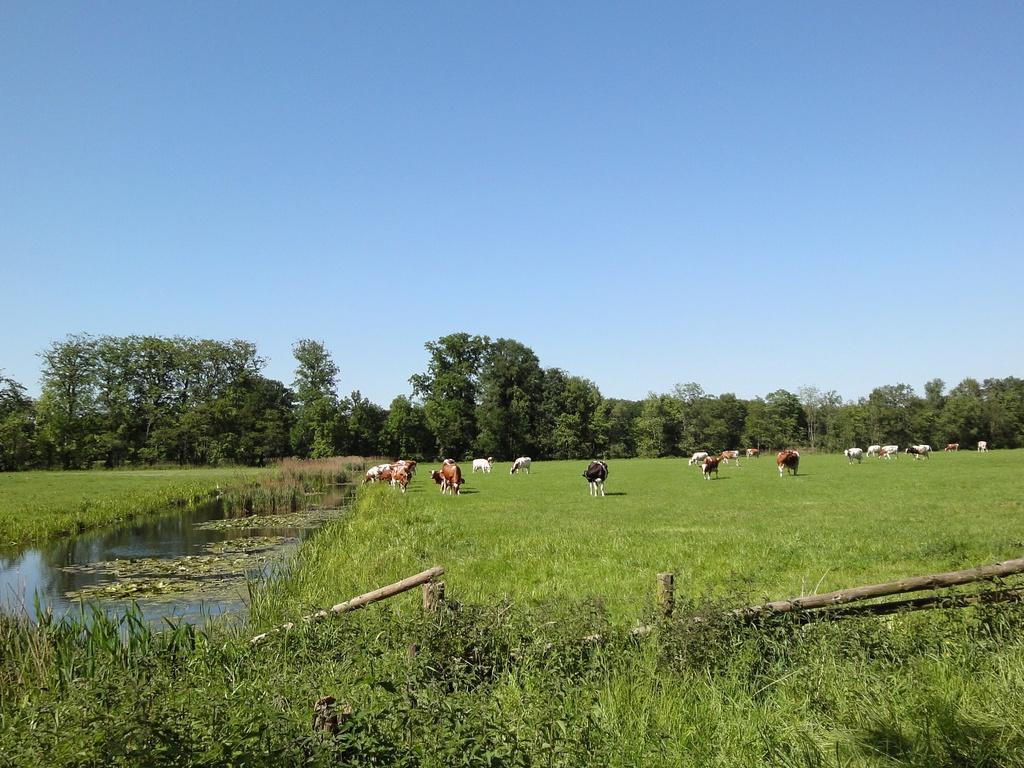Describe this image in one or two sentences. At the bottom of the picture, we see the grass. Beside that, we see the long wooden sticks. On the left side, we see water and this water might be in the pond. In the middle of the picture, we see the cows are grazing in the field. There are trees in the background. At the top, we see the sky, which is blue in color. 